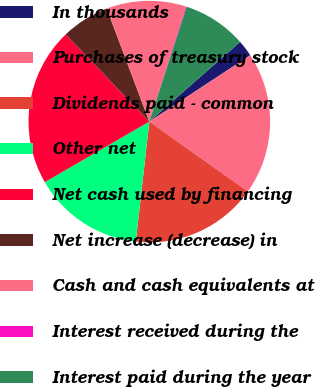Convert chart to OTSL. <chart><loc_0><loc_0><loc_500><loc_500><pie_chart><fcel>In thousands<fcel>Purchases of treasury stock<fcel>Dividends paid - common<fcel>Other net<fcel>Net cash used by financing<fcel>Net increase (decrease) in<fcel>Cash and cash equivalents at<fcel>Interest received during the<fcel>Interest paid during the year<nl><fcel>2.21%<fcel>19.08%<fcel>16.97%<fcel>14.86%<fcel>21.19%<fcel>6.43%<fcel>10.64%<fcel>0.1%<fcel>8.53%<nl></chart> 